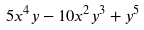Convert formula to latex. <formula><loc_0><loc_0><loc_500><loc_500>5 x ^ { 4 } y - 1 0 x ^ { 2 } y ^ { 3 } + y ^ { 5 }</formula> 